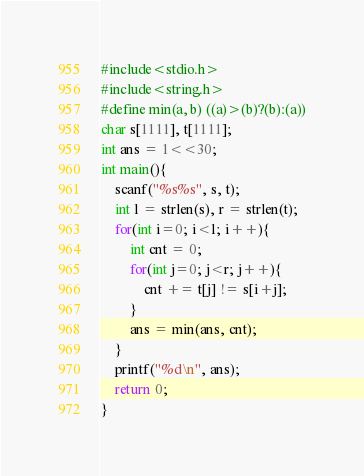Convert code to text. <code><loc_0><loc_0><loc_500><loc_500><_C_>#include<stdio.h>
#include<string.h>
#define min(a, b) ((a)>(b)?(b):(a))
char s[1111], t[1111];
int ans = 1<<30;
int main(){
	scanf("%s%s", s, t);
	int l = strlen(s), r = strlen(t);
	for(int i=0; i<l; i++){
		int cnt = 0;
		for(int j=0; j<r; j++){
			cnt += t[j] != s[i+j];
		}
		ans = min(ans, cnt);
	}
	printf("%d\n", ans);
	return 0;
}</code> 